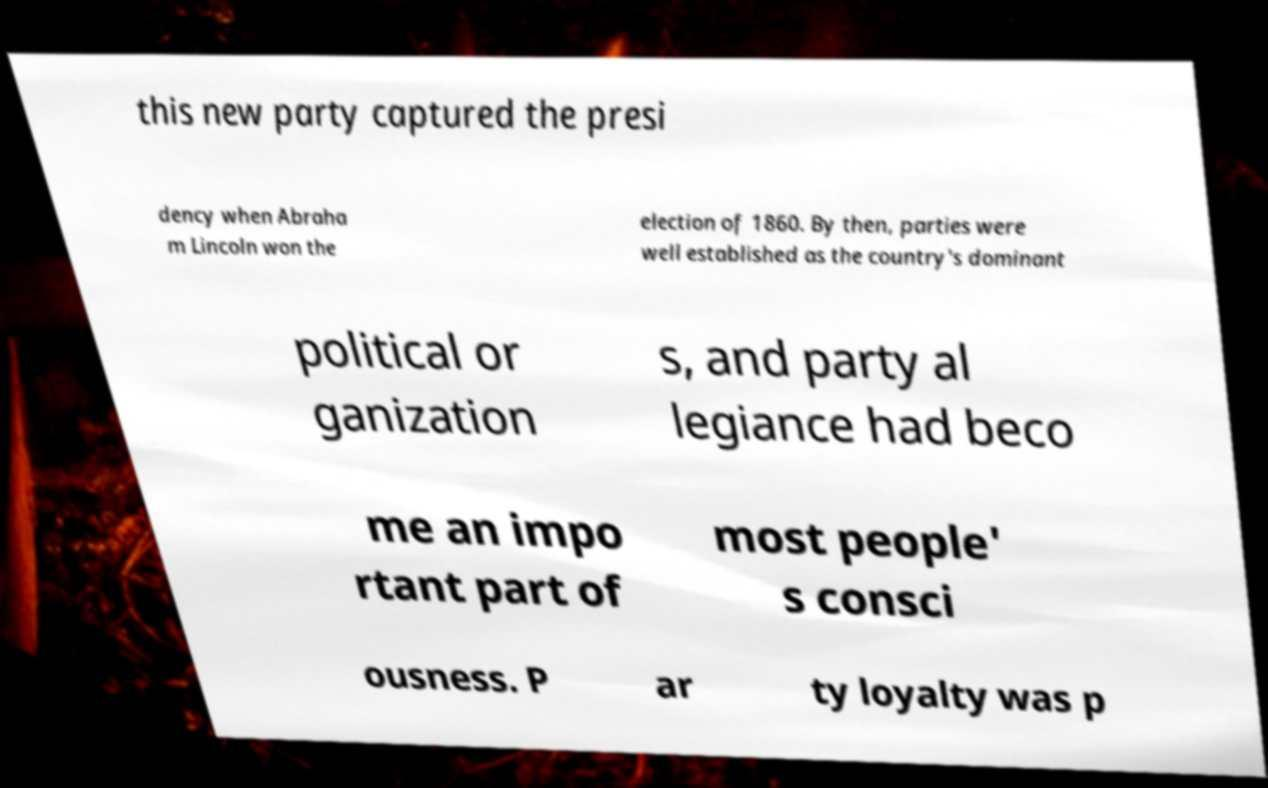For documentation purposes, I need the text within this image transcribed. Could you provide that? this new party captured the presi dency when Abraha m Lincoln won the election of 1860. By then, parties were well established as the country's dominant political or ganization s, and party al legiance had beco me an impo rtant part of most people' s consci ousness. P ar ty loyalty was p 